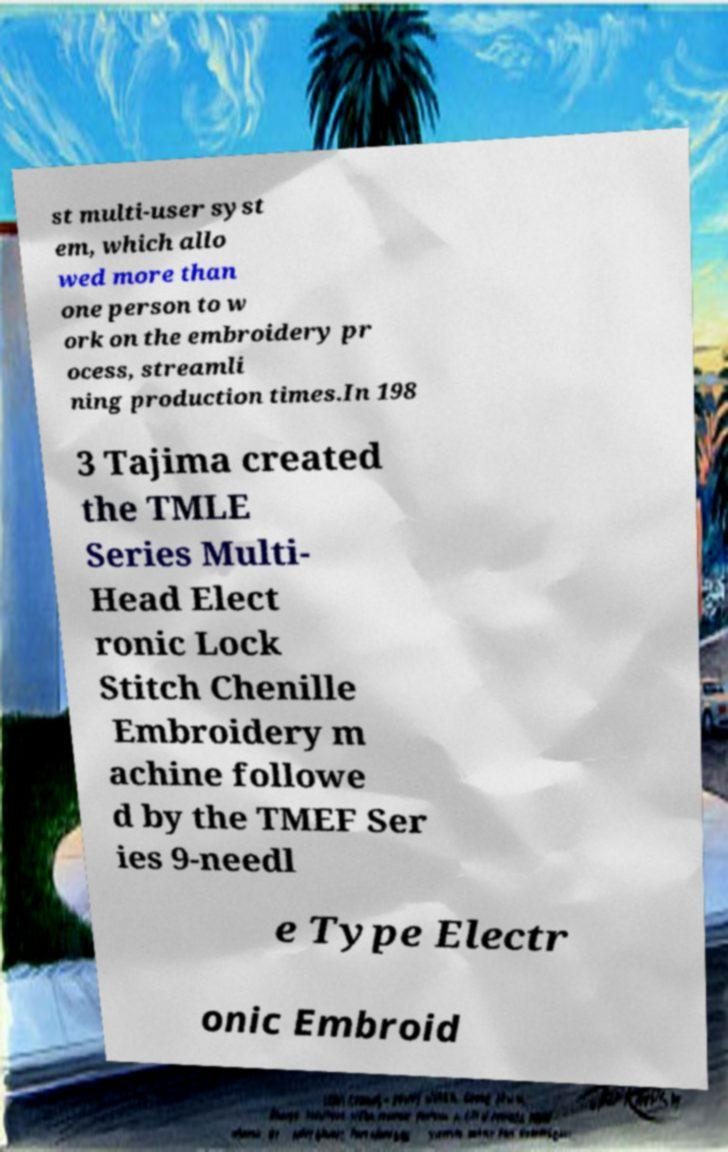Can you accurately transcribe the text from the provided image for me? st multi-user syst em, which allo wed more than one person to w ork on the embroidery pr ocess, streamli ning production times.In 198 3 Tajima created the TMLE Series Multi- Head Elect ronic Lock Stitch Chenille Embroidery m achine followe d by the TMEF Ser ies 9-needl e Type Electr onic Embroid 